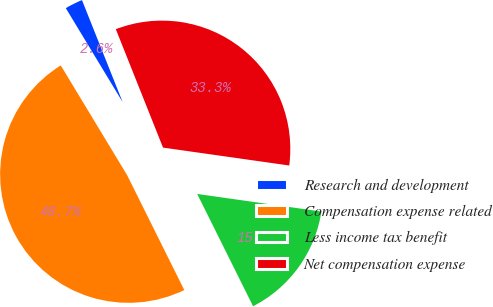Convert chart to OTSL. <chart><loc_0><loc_0><loc_500><loc_500><pie_chart><fcel>Research and development<fcel>Compensation expense related<fcel>Less income tax benefit<fcel>Net compensation expense<nl><fcel>2.62%<fcel>48.69%<fcel>15.41%<fcel>33.28%<nl></chart> 